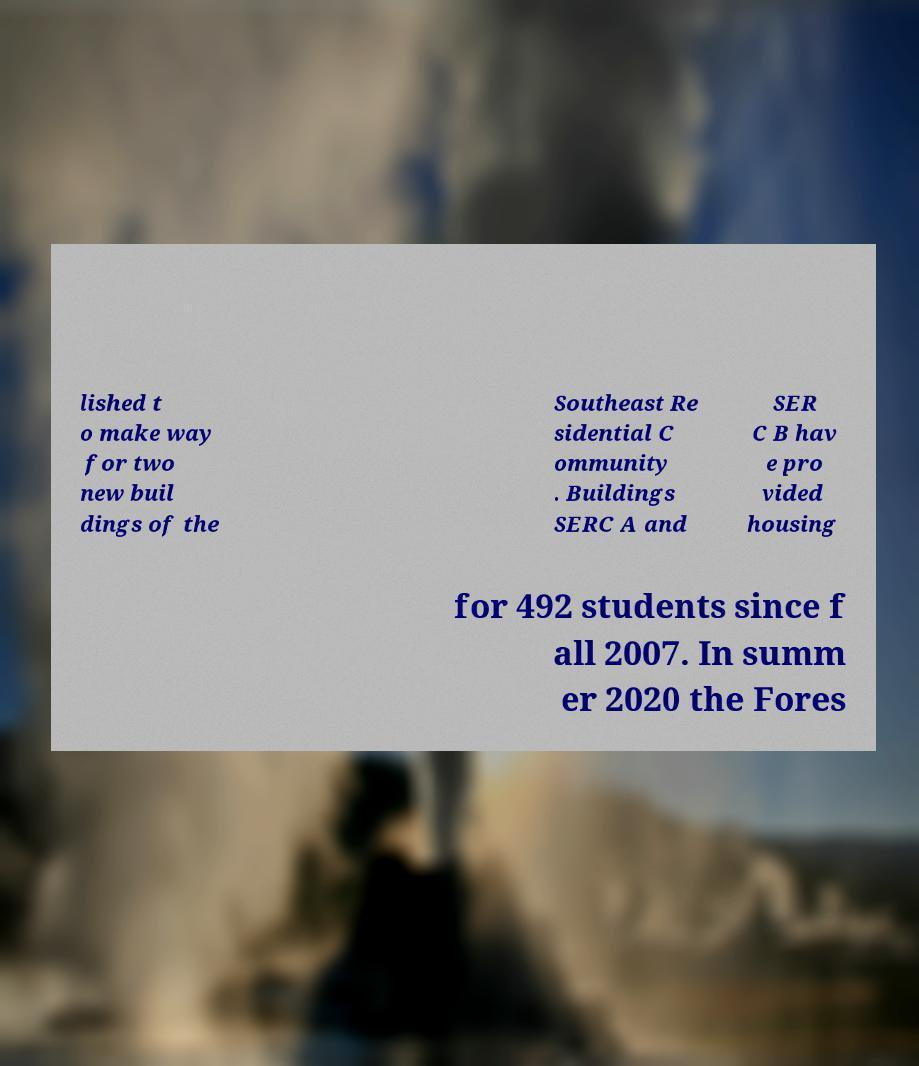Could you assist in decoding the text presented in this image and type it out clearly? lished t o make way for two new buil dings of the Southeast Re sidential C ommunity . Buildings SERC A and SER C B hav e pro vided housing for 492 students since f all 2007. In summ er 2020 the Fores 